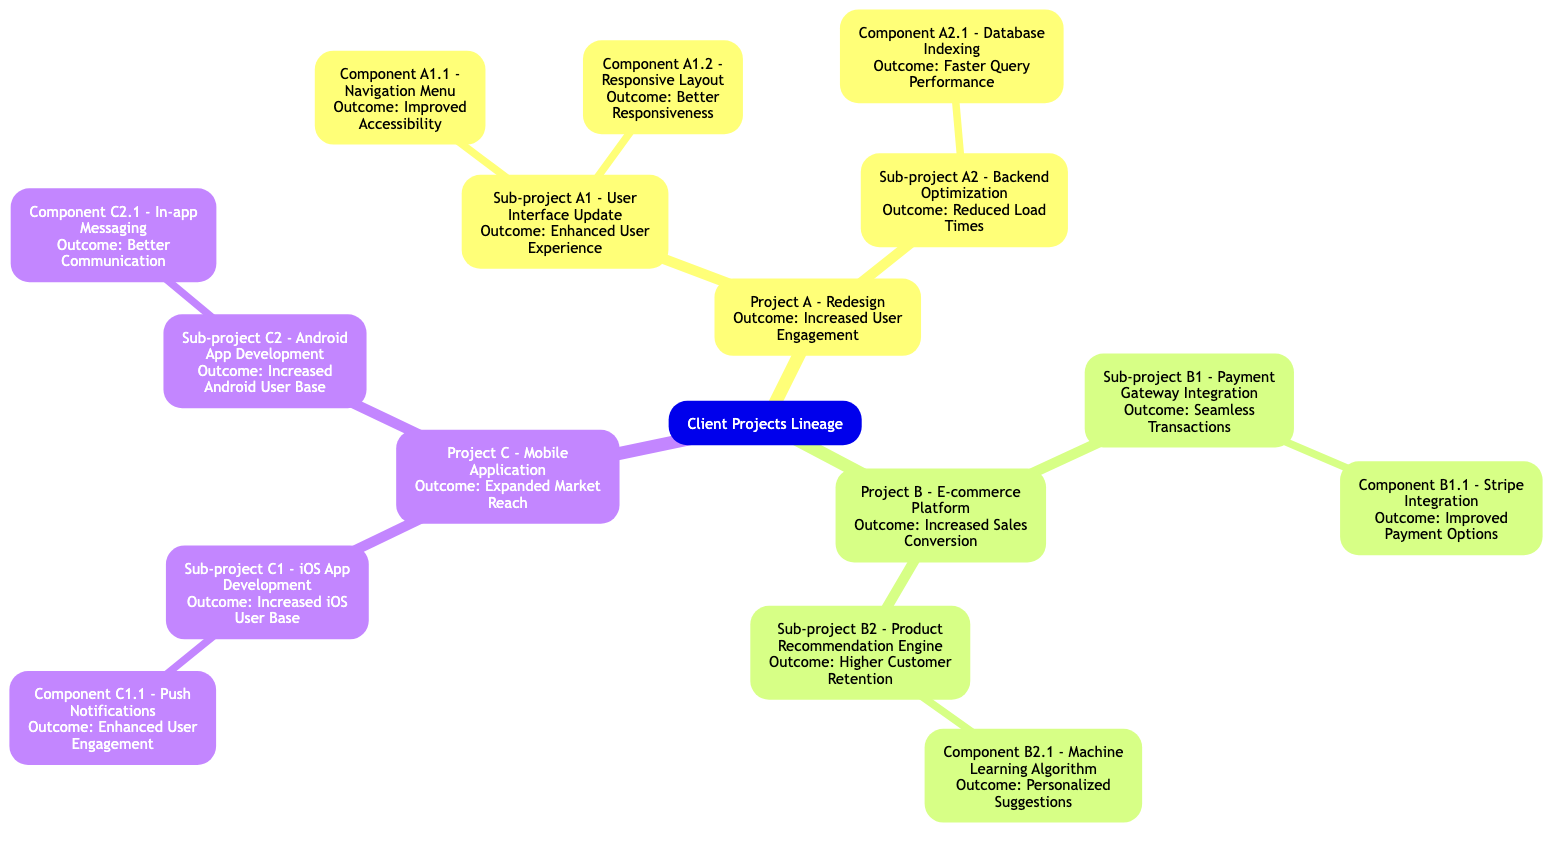What is the outcome of Project A? The diagram shows that Project A has an outcome labeled as "Increased User Engagement." This is explicitly stated as the outcome for Project A in the family tree structure.
Answer: Increased User Engagement How many sub-projects does Project B have? Looking at Project B in the diagram, there are two identified sub-projects: "Payment Gateway Integration" and "Product Recommendation Engine." Since there are two, the count is straightforward.
Answer: 2 What is the outcome of Component A1.1? The diagram indicates that Component A1.1, which is "Navigation Menu," has an outcome of "Improved Accessibility." This information is directly provided in the structure.
Answer: Improved Accessibility Which project has the outcome of "Higher Customer Retention"? Examining the diagram, the project that has the outcome "Higher Customer Retention" is Project B, specifically from the sub-project "Product Recommendation Engine." By identifying the branches, the project can be recognized clearly.
Answer: Project B Which component directly contributes to "Better Responsiveness"? The diagram specifies that the component responsible for "Better Responsiveness" is Component A1.2, named "Responsive Layout." This is a direct match in the diagram and identifies the component clearly.
Answer: Component A1.2 - Responsive Layout What is the relationship between Project C and its sub-projects? In the family tree, Project C branches into two sub-projects: "iOS App Development" and "Android App Development." This signifies that Project C encompasses both sub-projects under its lineage, relating them as parts contributing to Project C's overall success.
Answer: Sub-projects: C1 and C2 Which component is associated with "Enhanced User Engagement"? By reviewing the diagram, "Push Notifications," which is Component C1.1, is linked to the outcome "Enhanced User Engagement." This relationship is directly stated under the respective sub-project.
Answer: Component C1.1 - Push Notifications What is the common outcome for both sub-projects under Project A? The sub-projects under Project A, namely "User Interface Update" and "Backend Optimization," lead to outcomes of "Enhanced User Experience" and "Reduced Load Times," respectively. However, to find a common outcome, it is derived that both contribute towards improving overall user engagement, thus connecting with Project A's overall outcome.
Answer: Not directly common; related to user engagement How does Component B2.1 improve the platform? The diagram shows that Component B2.1, which is the "Machine Learning Algorithm," contributes to "Personalized Suggestions." This improvement in the platform relates to how it enhances customer experience and retention by offering tailored recommendations.
Answer: Personalized Suggestions 